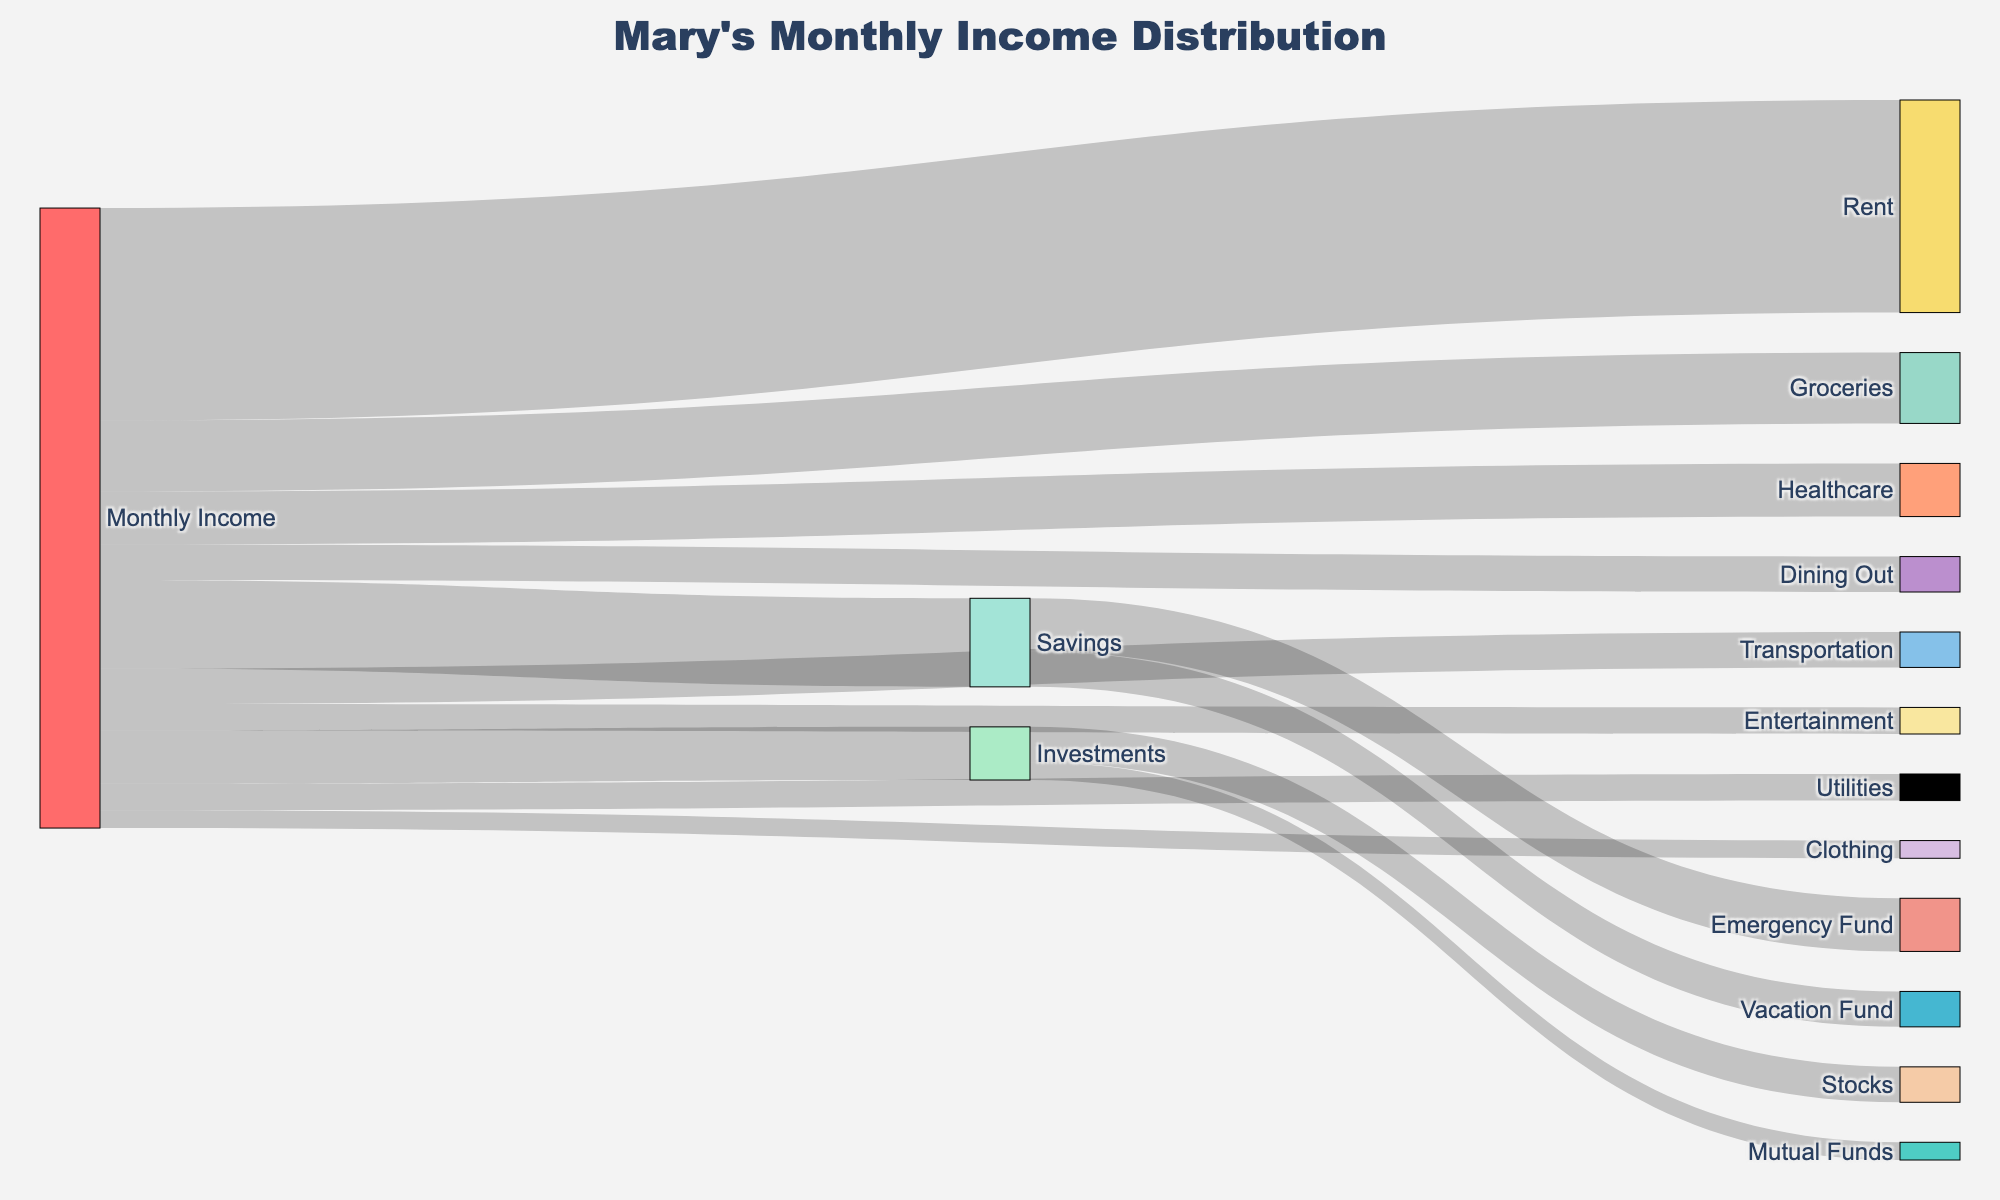How much of Mary's monthly income goes to Transportation? We look at the flow from "Monthly Income" to "Transportation" node. The value listed is 200. Therefore, $200 of Mary's monthly income goes to Transportation.
Answer: 200 What is the total amount allocated to Utilities and Entertainment? We identify the flows from "Monthly Income" to "Utilities" and "Entertainment" nodes, which are 150 and 150 respectively. Adding them together, we get 150 + 150 = 300.
Answer: 300 Which category receives the highest amount from Mary's monthly income? By observing the flows from "Monthly Income," we compare the amounts. "Rent" receives the highest amount at 1200.
Answer: Rent How much does Mary allocate to her Savings and Investments combined? We find the flows from "Monthly Income" to "Savings" and "Investments," which are 500 and 300, respectively. Adding them up, we get 500 + 300 = 800.
Answer: 800 Compare the amount allocated between Healthcare and Dining Out. Which one is higher and by how much? We observe the flows from "Monthly Income" to "Healthcare" and "Dining Out," which are 300 and 200, respectively. The difference is 300 - 200 = 100, with Healthcare being higher.
Answer: Healthcare by 100 How much is allocated from Mary's Savings to the Emergency Fund? We look at the flow from "Savings" to "Emergency Fund." The value listed is 300. Therefore, $300 is allocated to the Emergency Fund.
Answer: 300 What percentage of the total monthly income does Mary save? From the flow "Monthly Income" to "Savings," the amount is 500. Considering the total monthly income, which is the sum of all outflows, we sum all the values: 1200 + 400 + 150 + 200 + 300 + 150 + 200 + 100 + 500 + 300 = 3500. The percentage is (500 / 3500) * 100 = 14.29%.
Answer: 14.29% What is the total amount spent on Groceries and Clothing? Observing the flows from "Monthly Income," "Groceries" is 400, and "Clothing" is 100. Adding them together gives 400 + 100 = 500.
Answer: 500 How much more is spent on Rent compared to Utilities? The flow for "Rent" is 1200 and for "Utilities" is 150. The difference is 1200 - 150 = 1050.
Answer: 1050 